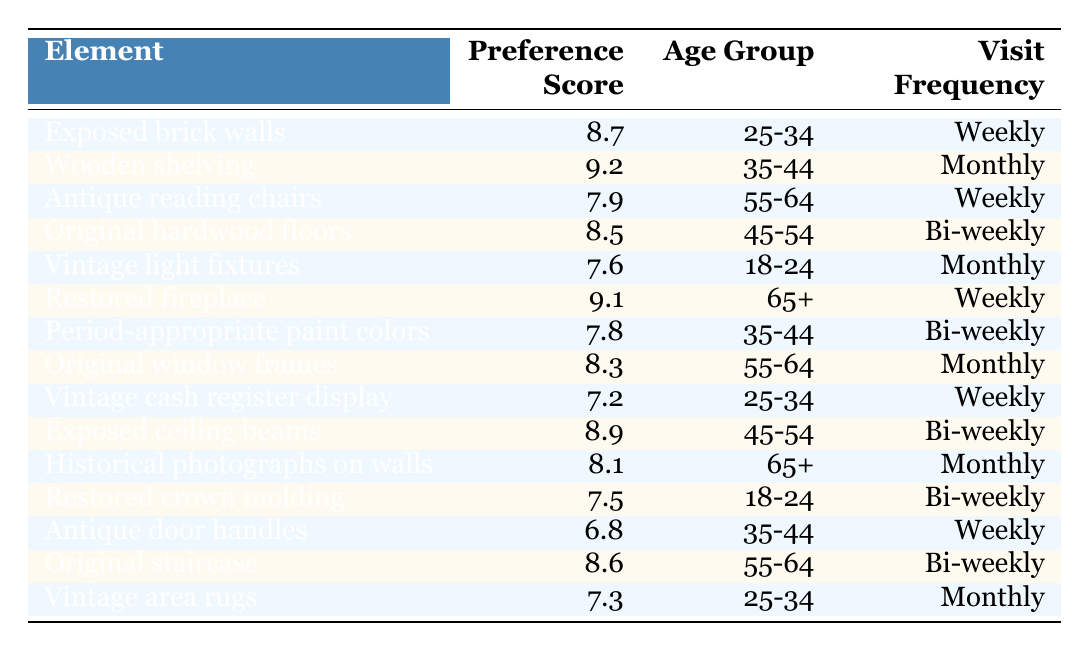What is the highest preference score among the elements? The highest preference score can be found by looking through the "Preference Score" column. The highest score is 9.2 for "Wooden shelving."
Answer: 9.2 Which age group prefers "Restored fireplace"? By checking the row for "Restored fireplace," we see that the corresponding age group is "65+."
Answer: 65+ What is the average preference score for the elements favored by age group 25-34? The preference scores for age group 25-34 are 8.7 (Exposed brick walls) and 7.2 (Vintage cash register display). The average is (8.7 + 7.2) / 2 = 7.95.
Answer: 7.95 Is there an element with a preference score lower than 7.5? By examining the "Preference Score" column, we can see that "Antique door handles" has a score of 6.8, which is lower than 7.5. Thus, the answer is yes.
Answer: Yes Which element has the lowest preference score and what is it? The lowest preference score can be found by scanning the "Preference Score" column. "Antique door handles" has the lowest score of 6.8.
Answer: Antique door handles, 6.8 How many elements have a preference score above 8.5? The elements with scores above 8.5 are "Wooden shelving" (9.2), "Restored fireplace" (9.1), "Exposed ceiling beams" (8.9), and "Original staircase" (8.6). Thus, there are four such elements.
Answer: 4 Which age group visits the bookstore monthly and prefers "Vintage light fixtures"? The row for "Vintage light fixtures" shows that the age group that visits monthly is "18-24."
Answer: 18-24 List all elements with a preference score greater than 8 and are favored by age group 45-54? The elements for age group 45-54 with scores greater than 8 are "Wooden shelving" (9.2), "Original hardwood floors" (8.5), and "Exposed ceiling beams" (8.9).
Answer: Wooden shelving, Original hardwood floors, Exposed ceiling beams How do the preference scores for age group 55-64 compare to those for age group 18-24? For age group 55-64, the scores are 7.9 (Antique reading chairs), 8.3 (Original window frames), and 8.6 (Original staircase), with an average score of (7.9 + 8.3 + 8.6) / 3 = 8.26. For age group 18-24, the scores are 7.6 (Vintage light fixtures) and 7.5 (Restored crown molding), with an average score of (7.6 + 7.5) / 2 = 7.55. Since 8.26 > 7.55, age group 55-64 has higher scores.
Answer: Age group 55-64 has higher scores Do more elements favor the "Weekly" visit frequency or the "Monthly" visit frequency? By counting, there are 6 elements with "Weekly" visit frequency (Exposed brick walls, Antique reading chairs, Vintage cash register display, Restored fireplace, Antique door handles, Original staircase), and 5 elements with "Monthly" (Wooden shelving, Vintage light fixtures, Original window frames, Historical photographs on walls, Vintage area rugs). Since 6 > 5, more elements favor "Weekly."
Answer: Weekly What is the preference score difference between "Exposed ceiling beams" and "Antique door handles"? "Exposed ceiling beams" has a score of 8.9 and "Antique door handles" has a score of 6.8. The difference is 8.9 - 6.8 = 2.1.
Answer: 2.1 